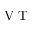Convert formula to latex. <formula><loc_0><loc_0><loc_500><loc_500>V T</formula> 